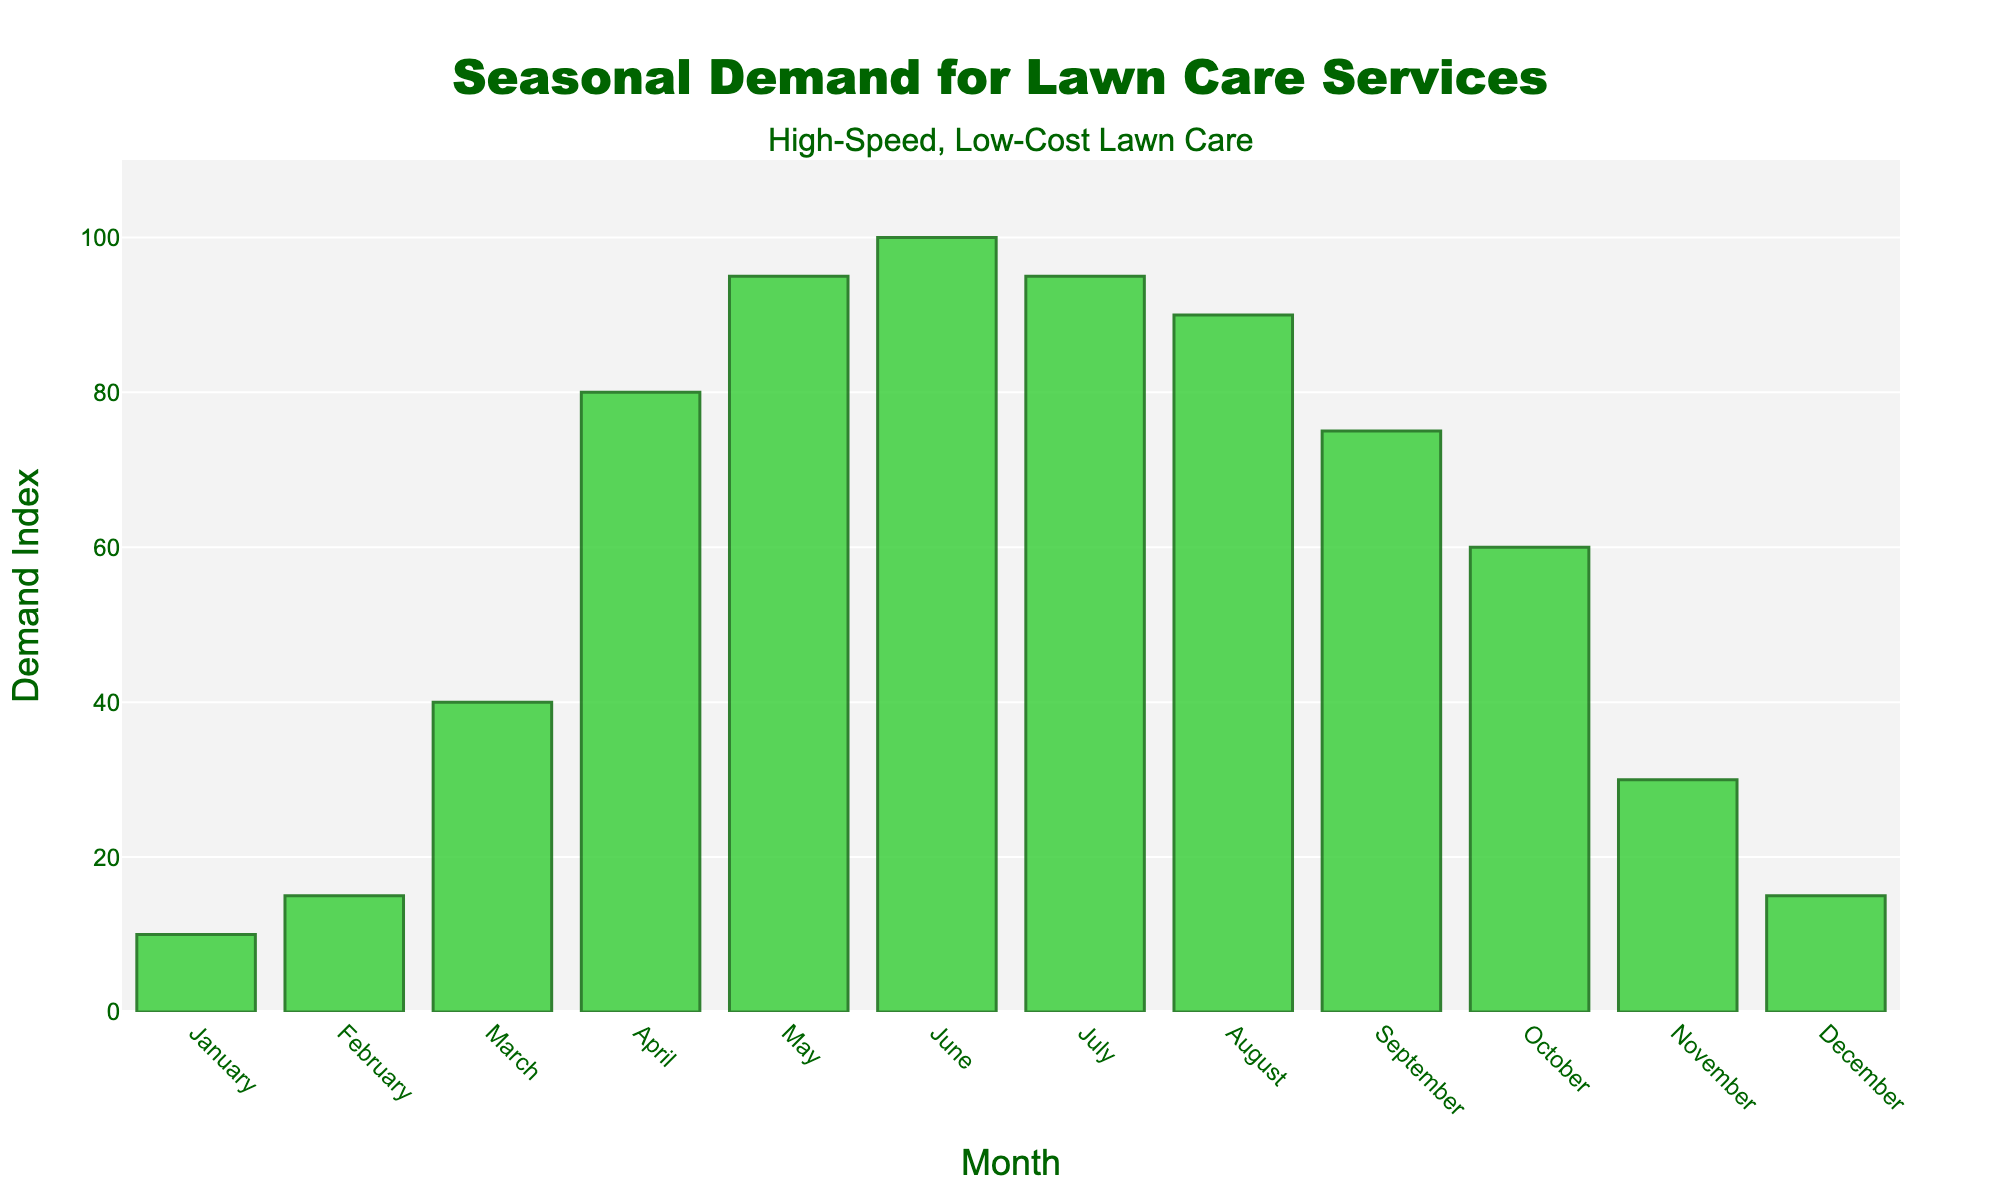Which month has the highest demand for lawn care services? By examining the heights of the bars, it's clear that the month with the highest bar represents the peak demand. Here, June has the tallest bar with a demand index of 100.
Answer: June Which month has the lowest demand for lawn care services? The shortest bar on the chart represents the lowest demand. January has the shortest bar with a demand index of 10.
Answer: January Compare the demand in June with that in December. To compare, observe the heights of the bars for June and December. June has a demand index of 100 while December has a demand index of 15. Thus, demand in June is significantly higher than in December.
Answer: June has a higher demand How does the demand in May compare to that in October? The bar for May reaches a height of 95, whereas the bar for October reaches a height of 60. Therefore, the demand in May is higher than in October.
Answer: May is higher What is the total demand index for the summer months (June, July, August)? To find the total for the summer months, add the demand indices for June (100), July (95), and August (90). The total is 100 + 95 + 90 = 285.
Answer: 285 Which months have a demand index greater than 50? The bars that exceed the 50 mark are April, May, June, July, August, September, and October. These months have a demand index greater than 50.
Answer: April, May, June, July, August, September, October What is the average demand index for the entire year? To calculate the average, sum all the demand indices and divide by the number of months. Sum = 10 + 15 + 40 + 80 + 95 + 100 + 95 + 90 + 75 + 60 + 30 + 15 = 705. Average = 705 / 12 ≈ 58.75
Answer: 58.75 What is the difference in demand between the highest and lowest months? The highest demand index is 100 (June) and the lowest is 10 (January). The difference is 100 - 10 = 90.
Answer: 90 Is there an upward or downward trend in demand from January to June? By following the bar heights from January to June, there is a clear upward trend in demand, with the heights of the bars progressively increasing each month.
Answer: Upward trend If the demand in March was doubled, what would the new demand index be for March? The original demand index for March is 40. Doubling this value gives 40 * 2 = 80.
Answer: 80 